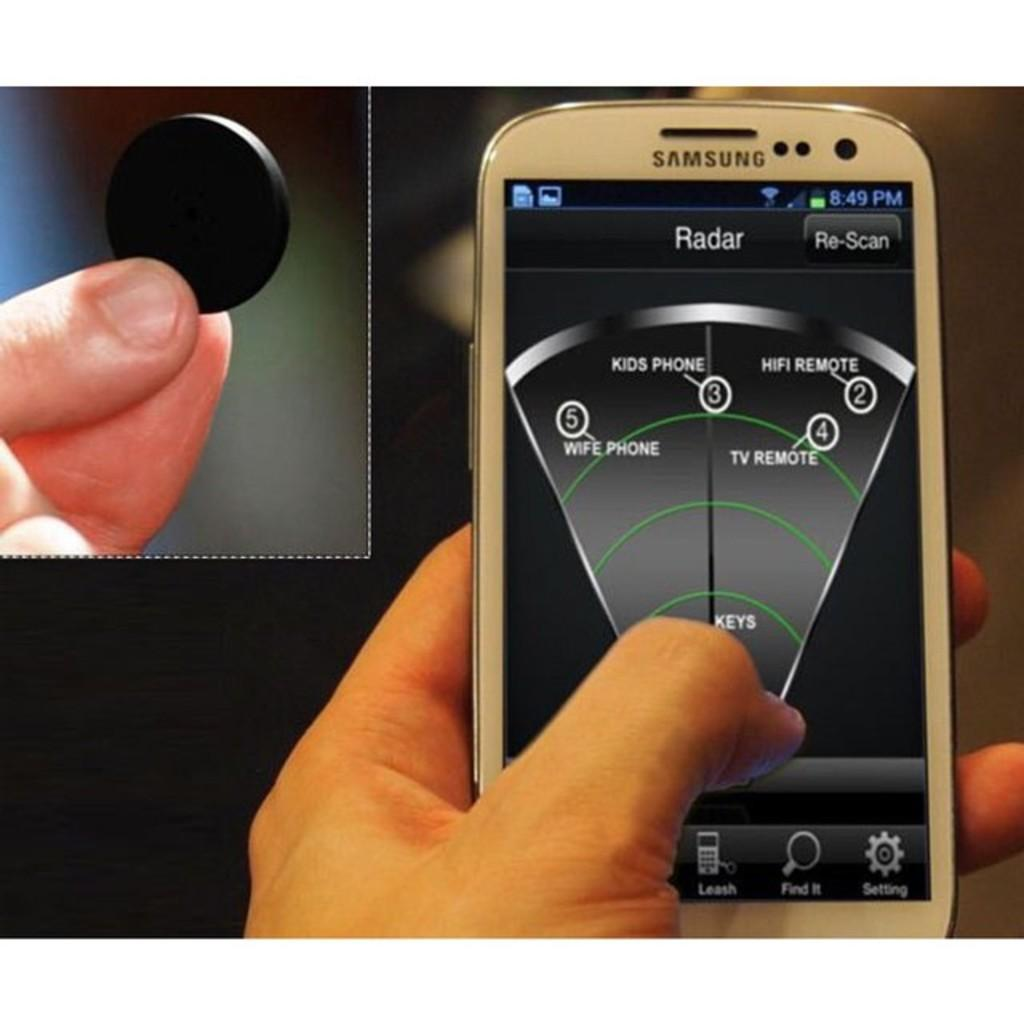Provide a one-sentence caption for the provided image. A white Samsung cellphone displaying a radar app. 